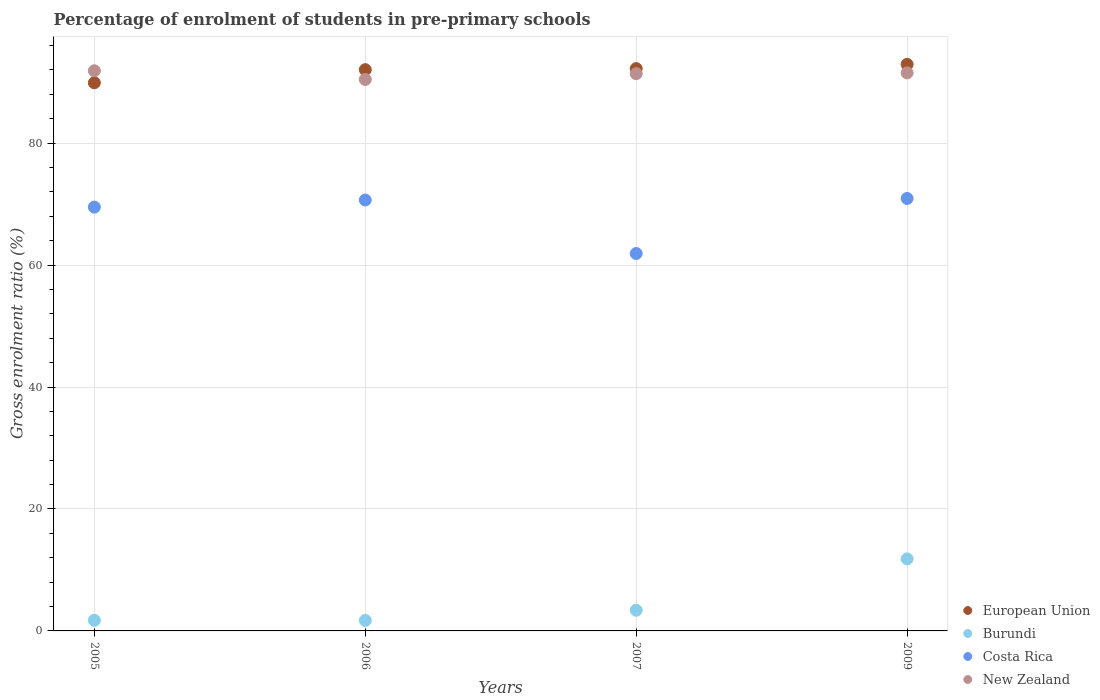What is the percentage of students enrolled in pre-primary schools in European Union in 2006?
Ensure brevity in your answer.  92.05. Across all years, what is the maximum percentage of students enrolled in pre-primary schools in Burundi?
Make the answer very short. 11.81. Across all years, what is the minimum percentage of students enrolled in pre-primary schools in Costa Rica?
Provide a succinct answer. 61.9. In which year was the percentage of students enrolled in pre-primary schools in Costa Rica maximum?
Ensure brevity in your answer.  2009. In which year was the percentage of students enrolled in pre-primary schools in New Zealand minimum?
Keep it short and to the point. 2006. What is the total percentage of students enrolled in pre-primary schools in Costa Rica in the graph?
Keep it short and to the point. 273.01. What is the difference between the percentage of students enrolled in pre-primary schools in New Zealand in 2005 and that in 2007?
Provide a succinct answer. 0.48. What is the difference between the percentage of students enrolled in pre-primary schools in European Union in 2006 and the percentage of students enrolled in pre-primary schools in Costa Rica in 2007?
Provide a short and direct response. 30.15. What is the average percentage of students enrolled in pre-primary schools in New Zealand per year?
Ensure brevity in your answer.  91.31. In the year 2005, what is the difference between the percentage of students enrolled in pre-primary schools in New Zealand and percentage of students enrolled in pre-primary schools in Costa Rica?
Offer a terse response. 22.37. In how many years, is the percentage of students enrolled in pre-primary schools in European Union greater than 8 %?
Your response must be concise. 4. What is the ratio of the percentage of students enrolled in pre-primary schools in European Union in 2007 to that in 2009?
Your response must be concise. 0.99. What is the difference between the highest and the second highest percentage of students enrolled in pre-primary schools in Costa Rica?
Provide a succinct answer. 0.25. What is the difference between the highest and the lowest percentage of students enrolled in pre-primary schools in Costa Rica?
Your answer should be very brief. 9.03. In how many years, is the percentage of students enrolled in pre-primary schools in New Zealand greater than the average percentage of students enrolled in pre-primary schools in New Zealand taken over all years?
Offer a very short reply. 3. Is the sum of the percentage of students enrolled in pre-primary schools in Burundi in 2006 and 2007 greater than the maximum percentage of students enrolled in pre-primary schools in European Union across all years?
Offer a terse response. No. Is it the case that in every year, the sum of the percentage of students enrolled in pre-primary schools in Burundi and percentage of students enrolled in pre-primary schools in New Zealand  is greater than the percentage of students enrolled in pre-primary schools in Costa Rica?
Ensure brevity in your answer.  Yes. Does the percentage of students enrolled in pre-primary schools in New Zealand monotonically increase over the years?
Provide a succinct answer. No. Is the percentage of students enrolled in pre-primary schools in European Union strictly less than the percentage of students enrolled in pre-primary schools in New Zealand over the years?
Make the answer very short. No. How many years are there in the graph?
Provide a succinct answer. 4. Does the graph contain any zero values?
Offer a terse response. No. Does the graph contain grids?
Keep it short and to the point. Yes. Where does the legend appear in the graph?
Your answer should be compact. Bottom right. How many legend labels are there?
Give a very brief answer. 4. How are the legend labels stacked?
Your response must be concise. Vertical. What is the title of the graph?
Offer a terse response. Percentage of enrolment of students in pre-primary schools. What is the Gross enrolment ratio (%) of European Union in 2005?
Provide a succinct answer. 89.91. What is the Gross enrolment ratio (%) of Burundi in 2005?
Make the answer very short. 1.74. What is the Gross enrolment ratio (%) of Costa Rica in 2005?
Offer a terse response. 69.51. What is the Gross enrolment ratio (%) in New Zealand in 2005?
Offer a terse response. 91.87. What is the Gross enrolment ratio (%) in European Union in 2006?
Your answer should be compact. 92.05. What is the Gross enrolment ratio (%) in Burundi in 2006?
Your response must be concise. 1.72. What is the Gross enrolment ratio (%) in Costa Rica in 2006?
Make the answer very short. 70.68. What is the Gross enrolment ratio (%) of New Zealand in 2006?
Give a very brief answer. 90.44. What is the Gross enrolment ratio (%) of European Union in 2007?
Your response must be concise. 92.22. What is the Gross enrolment ratio (%) in Burundi in 2007?
Give a very brief answer. 3.39. What is the Gross enrolment ratio (%) in Costa Rica in 2007?
Provide a short and direct response. 61.9. What is the Gross enrolment ratio (%) of New Zealand in 2007?
Your response must be concise. 91.4. What is the Gross enrolment ratio (%) of European Union in 2009?
Keep it short and to the point. 92.92. What is the Gross enrolment ratio (%) of Burundi in 2009?
Offer a very short reply. 11.81. What is the Gross enrolment ratio (%) of Costa Rica in 2009?
Keep it short and to the point. 70.93. What is the Gross enrolment ratio (%) in New Zealand in 2009?
Offer a very short reply. 91.53. Across all years, what is the maximum Gross enrolment ratio (%) of European Union?
Give a very brief answer. 92.92. Across all years, what is the maximum Gross enrolment ratio (%) in Burundi?
Your response must be concise. 11.81. Across all years, what is the maximum Gross enrolment ratio (%) of Costa Rica?
Provide a succinct answer. 70.93. Across all years, what is the maximum Gross enrolment ratio (%) in New Zealand?
Make the answer very short. 91.87. Across all years, what is the minimum Gross enrolment ratio (%) of European Union?
Your answer should be very brief. 89.91. Across all years, what is the minimum Gross enrolment ratio (%) in Burundi?
Ensure brevity in your answer.  1.72. Across all years, what is the minimum Gross enrolment ratio (%) of Costa Rica?
Offer a very short reply. 61.9. Across all years, what is the minimum Gross enrolment ratio (%) in New Zealand?
Your answer should be very brief. 90.44. What is the total Gross enrolment ratio (%) in European Union in the graph?
Offer a very short reply. 367.11. What is the total Gross enrolment ratio (%) of Burundi in the graph?
Give a very brief answer. 18.66. What is the total Gross enrolment ratio (%) in Costa Rica in the graph?
Provide a short and direct response. 273.01. What is the total Gross enrolment ratio (%) of New Zealand in the graph?
Give a very brief answer. 365.24. What is the difference between the Gross enrolment ratio (%) of European Union in 2005 and that in 2006?
Make the answer very short. -2.14. What is the difference between the Gross enrolment ratio (%) of Burundi in 2005 and that in 2006?
Offer a terse response. 0.02. What is the difference between the Gross enrolment ratio (%) in Costa Rica in 2005 and that in 2006?
Keep it short and to the point. -1.17. What is the difference between the Gross enrolment ratio (%) in New Zealand in 2005 and that in 2006?
Ensure brevity in your answer.  1.43. What is the difference between the Gross enrolment ratio (%) in European Union in 2005 and that in 2007?
Give a very brief answer. -2.31. What is the difference between the Gross enrolment ratio (%) of Burundi in 2005 and that in 2007?
Provide a short and direct response. -1.65. What is the difference between the Gross enrolment ratio (%) in Costa Rica in 2005 and that in 2007?
Offer a terse response. 7.61. What is the difference between the Gross enrolment ratio (%) of New Zealand in 2005 and that in 2007?
Offer a terse response. 0.48. What is the difference between the Gross enrolment ratio (%) of European Union in 2005 and that in 2009?
Offer a terse response. -3.01. What is the difference between the Gross enrolment ratio (%) of Burundi in 2005 and that in 2009?
Make the answer very short. -10.07. What is the difference between the Gross enrolment ratio (%) of Costa Rica in 2005 and that in 2009?
Your response must be concise. -1.42. What is the difference between the Gross enrolment ratio (%) in New Zealand in 2005 and that in 2009?
Provide a short and direct response. 0.34. What is the difference between the Gross enrolment ratio (%) of European Union in 2006 and that in 2007?
Your answer should be compact. -0.17. What is the difference between the Gross enrolment ratio (%) of Burundi in 2006 and that in 2007?
Provide a succinct answer. -1.68. What is the difference between the Gross enrolment ratio (%) in Costa Rica in 2006 and that in 2007?
Make the answer very short. 8.78. What is the difference between the Gross enrolment ratio (%) of New Zealand in 2006 and that in 2007?
Your answer should be compact. -0.95. What is the difference between the Gross enrolment ratio (%) in European Union in 2006 and that in 2009?
Keep it short and to the point. -0.87. What is the difference between the Gross enrolment ratio (%) in Burundi in 2006 and that in 2009?
Ensure brevity in your answer.  -10.1. What is the difference between the Gross enrolment ratio (%) of Costa Rica in 2006 and that in 2009?
Give a very brief answer. -0.25. What is the difference between the Gross enrolment ratio (%) of New Zealand in 2006 and that in 2009?
Your answer should be very brief. -1.08. What is the difference between the Gross enrolment ratio (%) of European Union in 2007 and that in 2009?
Your answer should be compact. -0.7. What is the difference between the Gross enrolment ratio (%) of Burundi in 2007 and that in 2009?
Offer a very short reply. -8.42. What is the difference between the Gross enrolment ratio (%) in Costa Rica in 2007 and that in 2009?
Offer a very short reply. -9.03. What is the difference between the Gross enrolment ratio (%) in New Zealand in 2007 and that in 2009?
Keep it short and to the point. -0.13. What is the difference between the Gross enrolment ratio (%) in European Union in 2005 and the Gross enrolment ratio (%) in Burundi in 2006?
Your answer should be compact. 88.19. What is the difference between the Gross enrolment ratio (%) of European Union in 2005 and the Gross enrolment ratio (%) of Costa Rica in 2006?
Offer a terse response. 19.23. What is the difference between the Gross enrolment ratio (%) in European Union in 2005 and the Gross enrolment ratio (%) in New Zealand in 2006?
Ensure brevity in your answer.  -0.54. What is the difference between the Gross enrolment ratio (%) of Burundi in 2005 and the Gross enrolment ratio (%) of Costa Rica in 2006?
Keep it short and to the point. -68.94. What is the difference between the Gross enrolment ratio (%) of Burundi in 2005 and the Gross enrolment ratio (%) of New Zealand in 2006?
Your answer should be compact. -88.71. What is the difference between the Gross enrolment ratio (%) of Costa Rica in 2005 and the Gross enrolment ratio (%) of New Zealand in 2006?
Your answer should be compact. -20.94. What is the difference between the Gross enrolment ratio (%) in European Union in 2005 and the Gross enrolment ratio (%) in Burundi in 2007?
Give a very brief answer. 86.52. What is the difference between the Gross enrolment ratio (%) in European Union in 2005 and the Gross enrolment ratio (%) in Costa Rica in 2007?
Give a very brief answer. 28.01. What is the difference between the Gross enrolment ratio (%) in European Union in 2005 and the Gross enrolment ratio (%) in New Zealand in 2007?
Provide a short and direct response. -1.49. What is the difference between the Gross enrolment ratio (%) of Burundi in 2005 and the Gross enrolment ratio (%) of Costa Rica in 2007?
Provide a succinct answer. -60.16. What is the difference between the Gross enrolment ratio (%) of Burundi in 2005 and the Gross enrolment ratio (%) of New Zealand in 2007?
Your answer should be compact. -89.66. What is the difference between the Gross enrolment ratio (%) of Costa Rica in 2005 and the Gross enrolment ratio (%) of New Zealand in 2007?
Your answer should be compact. -21.89. What is the difference between the Gross enrolment ratio (%) in European Union in 2005 and the Gross enrolment ratio (%) in Burundi in 2009?
Make the answer very short. 78.1. What is the difference between the Gross enrolment ratio (%) of European Union in 2005 and the Gross enrolment ratio (%) of Costa Rica in 2009?
Keep it short and to the point. 18.98. What is the difference between the Gross enrolment ratio (%) in European Union in 2005 and the Gross enrolment ratio (%) in New Zealand in 2009?
Your answer should be very brief. -1.62. What is the difference between the Gross enrolment ratio (%) in Burundi in 2005 and the Gross enrolment ratio (%) in Costa Rica in 2009?
Your response must be concise. -69.19. What is the difference between the Gross enrolment ratio (%) of Burundi in 2005 and the Gross enrolment ratio (%) of New Zealand in 2009?
Provide a succinct answer. -89.79. What is the difference between the Gross enrolment ratio (%) of Costa Rica in 2005 and the Gross enrolment ratio (%) of New Zealand in 2009?
Your answer should be compact. -22.02. What is the difference between the Gross enrolment ratio (%) in European Union in 2006 and the Gross enrolment ratio (%) in Burundi in 2007?
Offer a very short reply. 88.66. What is the difference between the Gross enrolment ratio (%) of European Union in 2006 and the Gross enrolment ratio (%) of Costa Rica in 2007?
Make the answer very short. 30.15. What is the difference between the Gross enrolment ratio (%) of European Union in 2006 and the Gross enrolment ratio (%) of New Zealand in 2007?
Provide a succinct answer. 0.66. What is the difference between the Gross enrolment ratio (%) in Burundi in 2006 and the Gross enrolment ratio (%) in Costa Rica in 2007?
Your answer should be very brief. -60.18. What is the difference between the Gross enrolment ratio (%) in Burundi in 2006 and the Gross enrolment ratio (%) in New Zealand in 2007?
Ensure brevity in your answer.  -89.68. What is the difference between the Gross enrolment ratio (%) of Costa Rica in 2006 and the Gross enrolment ratio (%) of New Zealand in 2007?
Provide a short and direct response. -20.72. What is the difference between the Gross enrolment ratio (%) in European Union in 2006 and the Gross enrolment ratio (%) in Burundi in 2009?
Your answer should be compact. 80.24. What is the difference between the Gross enrolment ratio (%) of European Union in 2006 and the Gross enrolment ratio (%) of Costa Rica in 2009?
Your answer should be very brief. 21.12. What is the difference between the Gross enrolment ratio (%) in European Union in 2006 and the Gross enrolment ratio (%) in New Zealand in 2009?
Ensure brevity in your answer.  0.53. What is the difference between the Gross enrolment ratio (%) of Burundi in 2006 and the Gross enrolment ratio (%) of Costa Rica in 2009?
Make the answer very short. -69.21. What is the difference between the Gross enrolment ratio (%) of Burundi in 2006 and the Gross enrolment ratio (%) of New Zealand in 2009?
Offer a very short reply. -89.81. What is the difference between the Gross enrolment ratio (%) in Costa Rica in 2006 and the Gross enrolment ratio (%) in New Zealand in 2009?
Make the answer very short. -20.85. What is the difference between the Gross enrolment ratio (%) in European Union in 2007 and the Gross enrolment ratio (%) in Burundi in 2009?
Offer a terse response. 80.41. What is the difference between the Gross enrolment ratio (%) in European Union in 2007 and the Gross enrolment ratio (%) in Costa Rica in 2009?
Ensure brevity in your answer.  21.29. What is the difference between the Gross enrolment ratio (%) of European Union in 2007 and the Gross enrolment ratio (%) of New Zealand in 2009?
Provide a succinct answer. 0.7. What is the difference between the Gross enrolment ratio (%) in Burundi in 2007 and the Gross enrolment ratio (%) in Costa Rica in 2009?
Ensure brevity in your answer.  -67.54. What is the difference between the Gross enrolment ratio (%) in Burundi in 2007 and the Gross enrolment ratio (%) in New Zealand in 2009?
Your answer should be compact. -88.14. What is the difference between the Gross enrolment ratio (%) of Costa Rica in 2007 and the Gross enrolment ratio (%) of New Zealand in 2009?
Provide a succinct answer. -29.63. What is the average Gross enrolment ratio (%) of European Union per year?
Ensure brevity in your answer.  91.78. What is the average Gross enrolment ratio (%) of Burundi per year?
Offer a terse response. 4.66. What is the average Gross enrolment ratio (%) of Costa Rica per year?
Make the answer very short. 68.25. What is the average Gross enrolment ratio (%) of New Zealand per year?
Your answer should be compact. 91.31. In the year 2005, what is the difference between the Gross enrolment ratio (%) in European Union and Gross enrolment ratio (%) in Burundi?
Keep it short and to the point. 88.17. In the year 2005, what is the difference between the Gross enrolment ratio (%) of European Union and Gross enrolment ratio (%) of Costa Rica?
Your answer should be very brief. 20.4. In the year 2005, what is the difference between the Gross enrolment ratio (%) in European Union and Gross enrolment ratio (%) in New Zealand?
Your answer should be very brief. -1.96. In the year 2005, what is the difference between the Gross enrolment ratio (%) in Burundi and Gross enrolment ratio (%) in Costa Rica?
Provide a succinct answer. -67.77. In the year 2005, what is the difference between the Gross enrolment ratio (%) in Burundi and Gross enrolment ratio (%) in New Zealand?
Offer a terse response. -90.13. In the year 2005, what is the difference between the Gross enrolment ratio (%) in Costa Rica and Gross enrolment ratio (%) in New Zealand?
Give a very brief answer. -22.37. In the year 2006, what is the difference between the Gross enrolment ratio (%) of European Union and Gross enrolment ratio (%) of Burundi?
Keep it short and to the point. 90.34. In the year 2006, what is the difference between the Gross enrolment ratio (%) in European Union and Gross enrolment ratio (%) in Costa Rica?
Ensure brevity in your answer.  21.38. In the year 2006, what is the difference between the Gross enrolment ratio (%) in European Union and Gross enrolment ratio (%) in New Zealand?
Give a very brief answer. 1.61. In the year 2006, what is the difference between the Gross enrolment ratio (%) of Burundi and Gross enrolment ratio (%) of Costa Rica?
Offer a very short reply. -68.96. In the year 2006, what is the difference between the Gross enrolment ratio (%) in Burundi and Gross enrolment ratio (%) in New Zealand?
Keep it short and to the point. -88.73. In the year 2006, what is the difference between the Gross enrolment ratio (%) of Costa Rica and Gross enrolment ratio (%) of New Zealand?
Provide a succinct answer. -19.77. In the year 2007, what is the difference between the Gross enrolment ratio (%) in European Union and Gross enrolment ratio (%) in Burundi?
Keep it short and to the point. 88.83. In the year 2007, what is the difference between the Gross enrolment ratio (%) in European Union and Gross enrolment ratio (%) in Costa Rica?
Keep it short and to the point. 30.33. In the year 2007, what is the difference between the Gross enrolment ratio (%) of European Union and Gross enrolment ratio (%) of New Zealand?
Your response must be concise. 0.83. In the year 2007, what is the difference between the Gross enrolment ratio (%) of Burundi and Gross enrolment ratio (%) of Costa Rica?
Provide a short and direct response. -58.51. In the year 2007, what is the difference between the Gross enrolment ratio (%) in Burundi and Gross enrolment ratio (%) in New Zealand?
Provide a short and direct response. -88.01. In the year 2007, what is the difference between the Gross enrolment ratio (%) of Costa Rica and Gross enrolment ratio (%) of New Zealand?
Ensure brevity in your answer.  -29.5. In the year 2009, what is the difference between the Gross enrolment ratio (%) in European Union and Gross enrolment ratio (%) in Burundi?
Keep it short and to the point. 81.11. In the year 2009, what is the difference between the Gross enrolment ratio (%) of European Union and Gross enrolment ratio (%) of Costa Rica?
Ensure brevity in your answer.  21.99. In the year 2009, what is the difference between the Gross enrolment ratio (%) in European Union and Gross enrolment ratio (%) in New Zealand?
Ensure brevity in your answer.  1.39. In the year 2009, what is the difference between the Gross enrolment ratio (%) in Burundi and Gross enrolment ratio (%) in Costa Rica?
Your answer should be very brief. -59.12. In the year 2009, what is the difference between the Gross enrolment ratio (%) of Burundi and Gross enrolment ratio (%) of New Zealand?
Your answer should be compact. -79.72. In the year 2009, what is the difference between the Gross enrolment ratio (%) in Costa Rica and Gross enrolment ratio (%) in New Zealand?
Offer a very short reply. -20.6. What is the ratio of the Gross enrolment ratio (%) of European Union in 2005 to that in 2006?
Give a very brief answer. 0.98. What is the ratio of the Gross enrolment ratio (%) in Burundi in 2005 to that in 2006?
Ensure brevity in your answer.  1.01. What is the ratio of the Gross enrolment ratio (%) of Costa Rica in 2005 to that in 2006?
Provide a succinct answer. 0.98. What is the ratio of the Gross enrolment ratio (%) of New Zealand in 2005 to that in 2006?
Ensure brevity in your answer.  1.02. What is the ratio of the Gross enrolment ratio (%) of European Union in 2005 to that in 2007?
Keep it short and to the point. 0.97. What is the ratio of the Gross enrolment ratio (%) in Burundi in 2005 to that in 2007?
Give a very brief answer. 0.51. What is the ratio of the Gross enrolment ratio (%) of Costa Rica in 2005 to that in 2007?
Provide a succinct answer. 1.12. What is the ratio of the Gross enrolment ratio (%) of New Zealand in 2005 to that in 2007?
Your answer should be compact. 1.01. What is the ratio of the Gross enrolment ratio (%) of European Union in 2005 to that in 2009?
Offer a terse response. 0.97. What is the ratio of the Gross enrolment ratio (%) of Burundi in 2005 to that in 2009?
Your answer should be very brief. 0.15. What is the ratio of the Gross enrolment ratio (%) in Costa Rica in 2005 to that in 2009?
Make the answer very short. 0.98. What is the ratio of the Gross enrolment ratio (%) of Burundi in 2006 to that in 2007?
Your response must be concise. 0.51. What is the ratio of the Gross enrolment ratio (%) of Costa Rica in 2006 to that in 2007?
Your response must be concise. 1.14. What is the ratio of the Gross enrolment ratio (%) in New Zealand in 2006 to that in 2007?
Your response must be concise. 0.99. What is the ratio of the Gross enrolment ratio (%) in European Union in 2006 to that in 2009?
Ensure brevity in your answer.  0.99. What is the ratio of the Gross enrolment ratio (%) of Burundi in 2006 to that in 2009?
Keep it short and to the point. 0.15. What is the ratio of the Gross enrolment ratio (%) of Costa Rica in 2006 to that in 2009?
Keep it short and to the point. 1. What is the ratio of the Gross enrolment ratio (%) in New Zealand in 2006 to that in 2009?
Your answer should be compact. 0.99. What is the ratio of the Gross enrolment ratio (%) of Burundi in 2007 to that in 2009?
Provide a succinct answer. 0.29. What is the ratio of the Gross enrolment ratio (%) in Costa Rica in 2007 to that in 2009?
Offer a terse response. 0.87. What is the difference between the highest and the second highest Gross enrolment ratio (%) in European Union?
Give a very brief answer. 0.7. What is the difference between the highest and the second highest Gross enrolment ratio (%) in Burundi?
Offer a very short reply. 8.42. What is the difference between the highest and the second highest Gross enrolment ratio (%) in Costa Rica?
Provide a succinct answer. 0.25. What is the difference between the highest and the second highest Gross enrolment ratio (%) of New Zealand?
Give a very brief answer. 0.34. What is the difference between the highest and the lowest Gross enrolment ratio (%) in European Union?
Your response must be concise. 3.01. What is the difference between the highest and the lowest Gross enrolment ratio (%) of Burundi?
Your response must be concise. 10.1. What is the difference between the highest and the lowest Gross enrolment ratio (%) in Costa Rica?
Give a very brief answer. 9.03. What is the difference between the highest and the lowest Gross enrolment ratio (%) of New Zealand?
Make the answer very short. 1.43. 